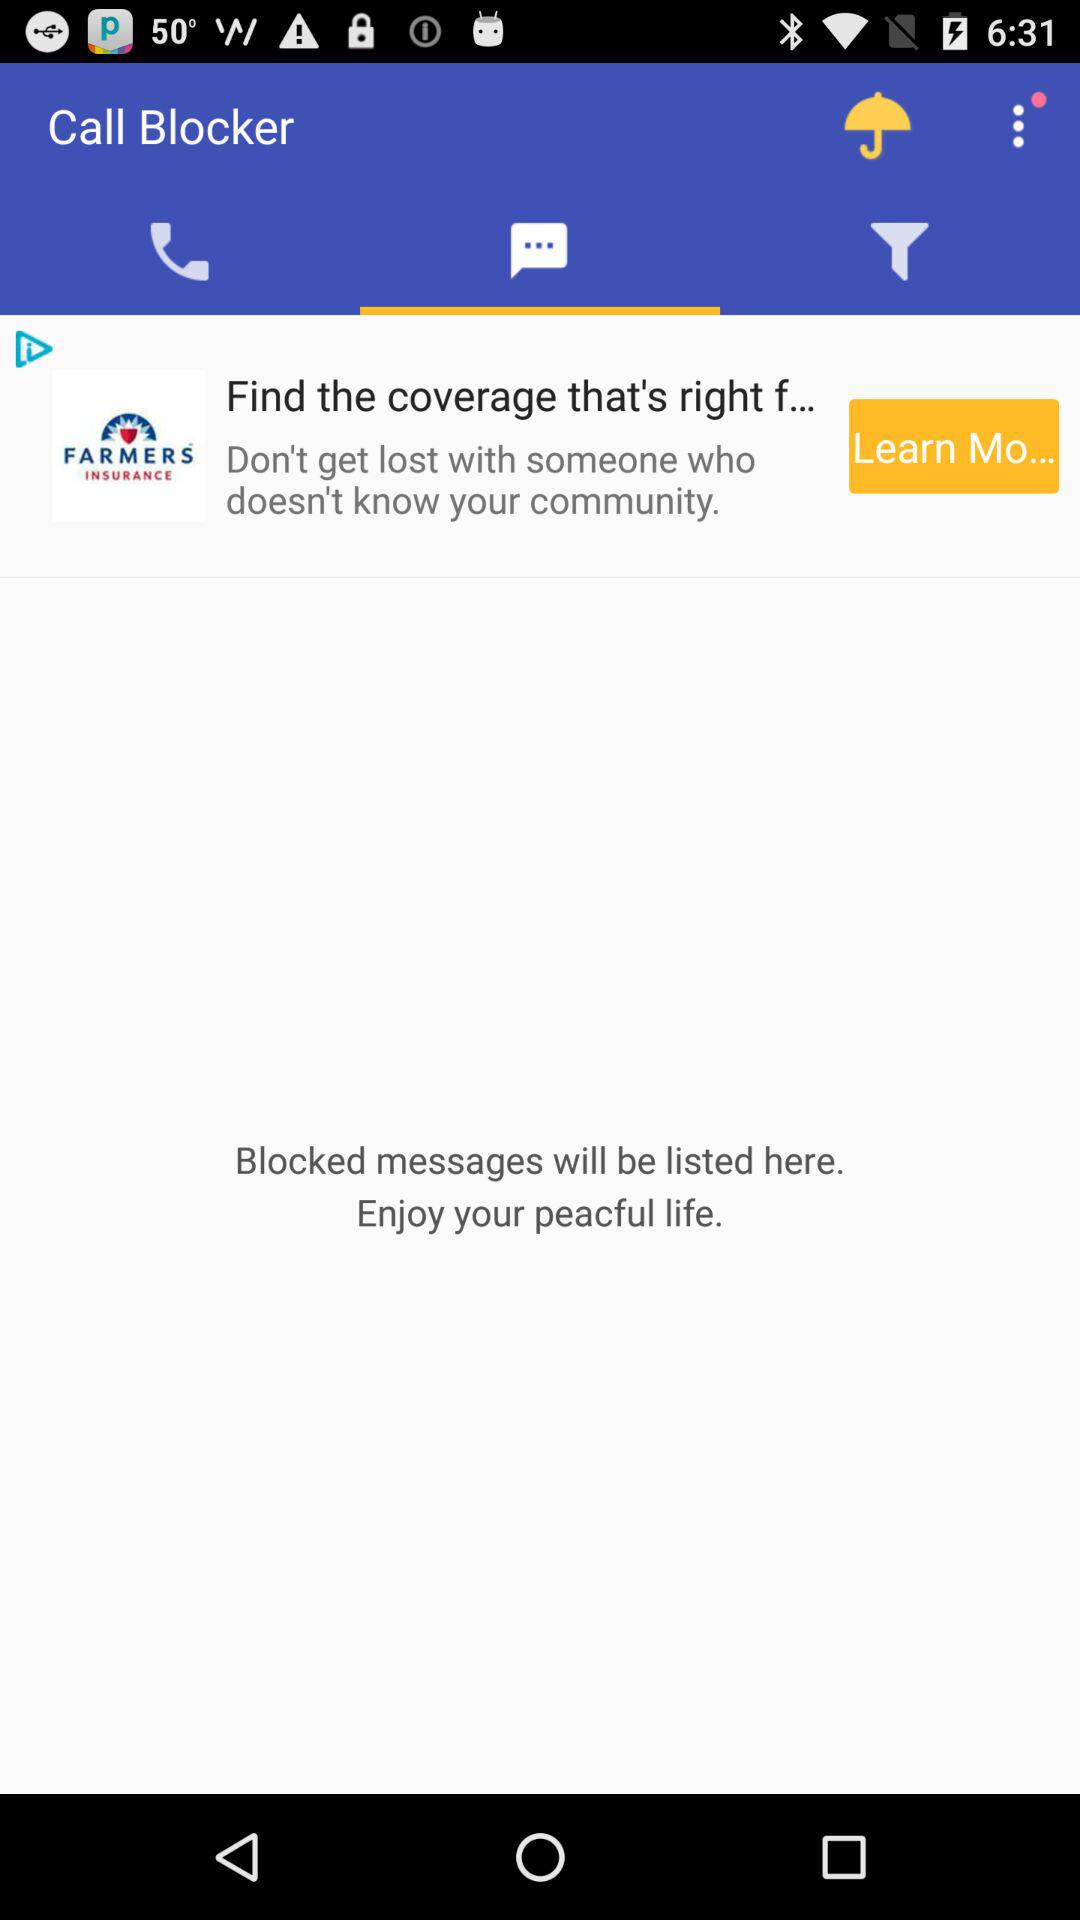Which tab is selected? The selected tab is messages. 